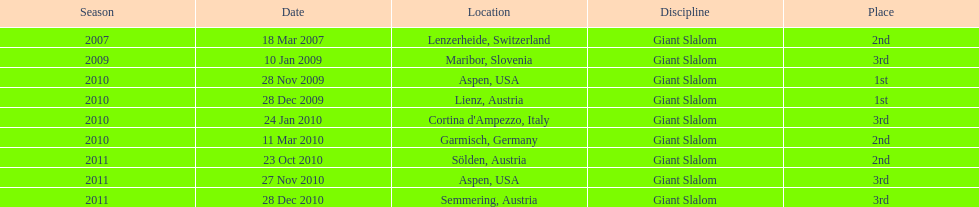Aspen and lienz in 2009 are the only races where this racer got what position? 1st. 